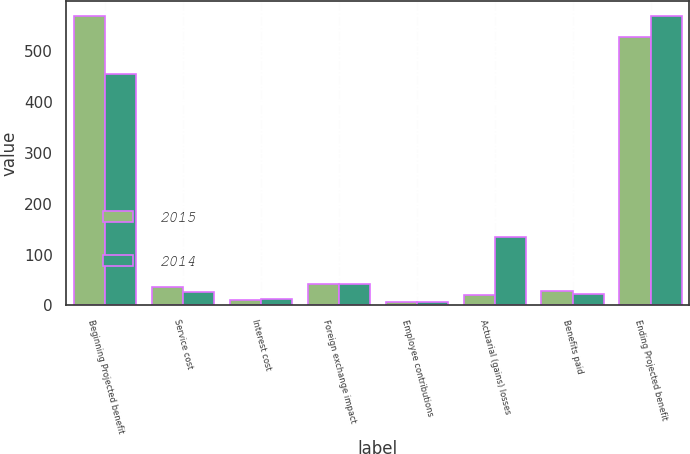<chart> <loc_0><loc_0><loc_500><loc_500><stacked_bar_chart><ecel><fcel>Beginning Projected benefit<fcel>Service cost<fcel>Interest cost<fcel>Foreign exchange impact<fcel>Employee contributions<fcel>Actuarial (gains) losses<fcel>Benefits paid<fcel>Ending Projected benefit<nl><fcel>2015<fcel>570<fcel>36<fcel>10<fcel>43<fcel>6<fcel>21<fcel>29<fcel>529<nl><fcel>2014<fcel>456<fcel>26<fcel>13<fcel>43<fcel>6<fcel>134<fcel>22<fcel>570<nl></chart> 